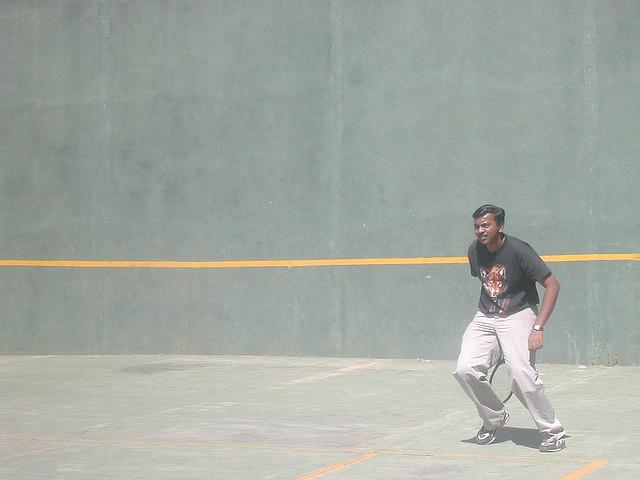Why is the fence so high around the court?
Give a very brief answer. Safety. Is the man wearing pants?
Concise answer only. Yes. What is drawn on the man s t shirt?
Short answer required. Wolf. What is the man holding?
Give a very brief answer. Tennis racket. 